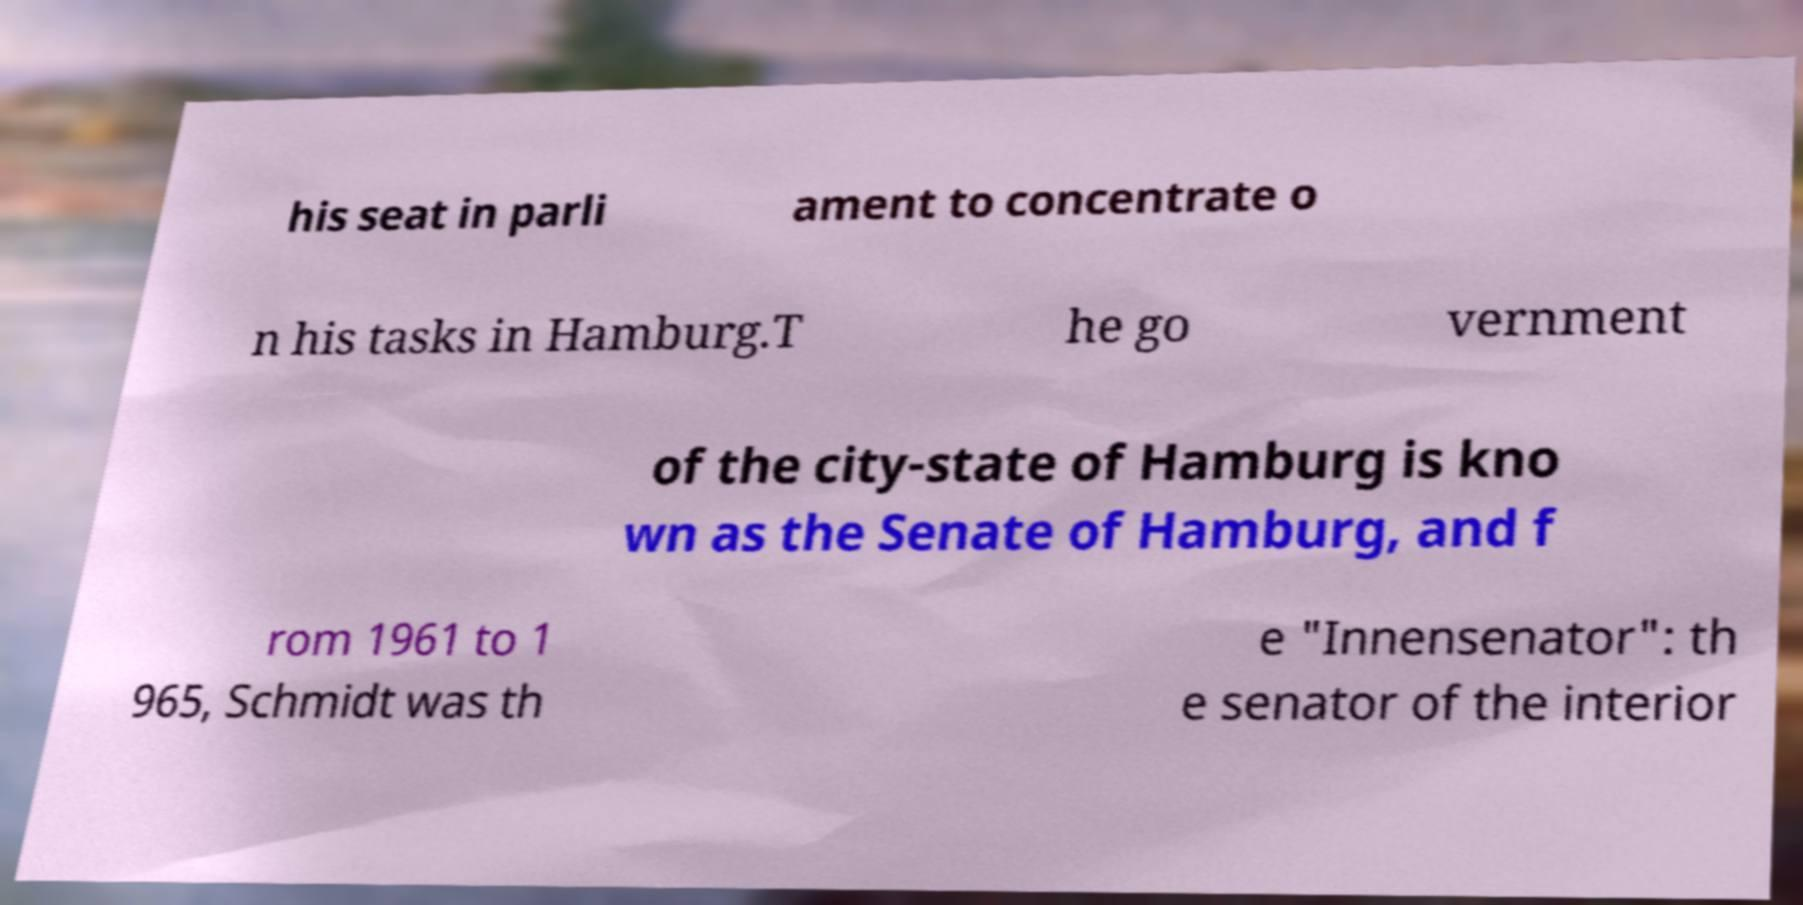Please identify and transcribe the text found in this image. his seat in parli ament to concentrate o n his tasks in Hamburg.T he go vernment of the city-state of Hamburg is kno wn as the Senate of Hamburg, and f rom 1961 to 1 965, Schmidt was th e "Innensenator": th e senator of the interior 